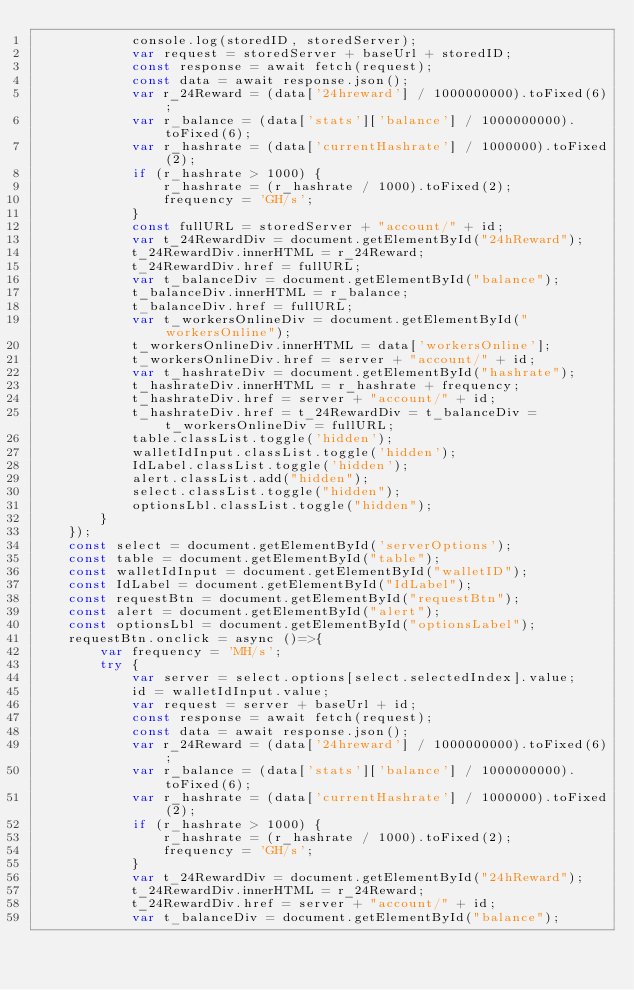Convert code to text. <code><loc_0><loc_0><loc_500><loc_500><_JavaScript_>            console.log(storedID, storedServer);
            var request = storedServer + baseUrl + storedID;
            const response = await fetch(request);
            const data = await response.json();
            var r_24Reward = (data['24hreward'] / 1000000000).toFixed(6);
            var r_balance = (data['stats']['balance'] / 1000000000).toFixed(6);
            var r_hashrate = (data['currentHashrate'] / 1000000).toFixed(2);
            if (r_hashrate > 1000) {
                r_hashrate = (r_hashrate / 1000).toFixed(2);
                frequency = 'GH/s';
            }
            const fullURL = storedServer + "account/" + id;
            var t_24RewardDiv = document.getElementById("24hReward");
            t_24RewardDiv.innerHTML = r_24Reward;
            t_24RewardDiv.href = fullURL;
            var t_balanceDiv = document.getElementById("balance");
            t_balanceDiv.innerHTML = r_balance;
            t_balanceDiv.href = fullURL;
            var t_workersOnlineDiv = document.getElementById("workersOnline");
            t_workersOnlineDiv.innerHTML = data['workersOnline'];
            t_workersOnlineDiv.href = server + "account/" + id;
            var t_hashrateDiv = document.getElementById("hashrate");
            t_hashrateDiv.innerHTML = r_hashrate + frequency;
            t_hashrateDiv.href = server + "account/" + id;
            t_hashrateDiv.href = t_24RewardDiv = t_balanceDiv = t_workersOnlineDiv = fullURL;
            table.classList.toggle('hidden');
            walletIdInput.classList.toggle('hidden');
            IdLabel.classList.toggle('hidden');
            alert.classList.add("hidden");
            select.classList.toggle("hidden");
            optionsLbl.classList.toggle("hidden");
        }
    });
    const select = document.getElementById('serverOptions');
    const table = document.getElementById("table");
    const walletIdInput = document.getElementById("walletID");
    const IdLabel = document.getElementById("IdLabel");
    const requestBtn = document.getElementById("requestBtn");
    const alert = document.getElementById("alert");
    const optionsLbl = document.getElementById("optionsLabel");
    requestBtn.onclick = async ()=>{
        var frequency = 'MH/s';
        try {
            var server = select.options[select.selectedIndex].value;
            id = walletIdInput.value;
            var request = server + baseUrl + id;
            const response = await fetch(request);
            const data = await response.json();
            var r_24Reward = (data['24hreward'] / 1000000000).toFixed(6);
            var r_balance = (data['stats']['balance'] / 1000000000).toFixed(6);
            var r_hashrate = (data['currentHashrate'] / 1000000).toFixed(2);
            if (r_hashrate > 1000) {
                r_hashrate = (r_hashrate / 1000).toFixed(2);
                frequency = 'GH/s';
            }
            var t_24RewardDiv = document.getElementById("24hReward");
            t_24RewardDiv.innerHTML = r_24Reward;
            t_24RewardDiv.href = server + "account/" + id;
            var t_balanceDiv = document.getElementById("balance");</code> 